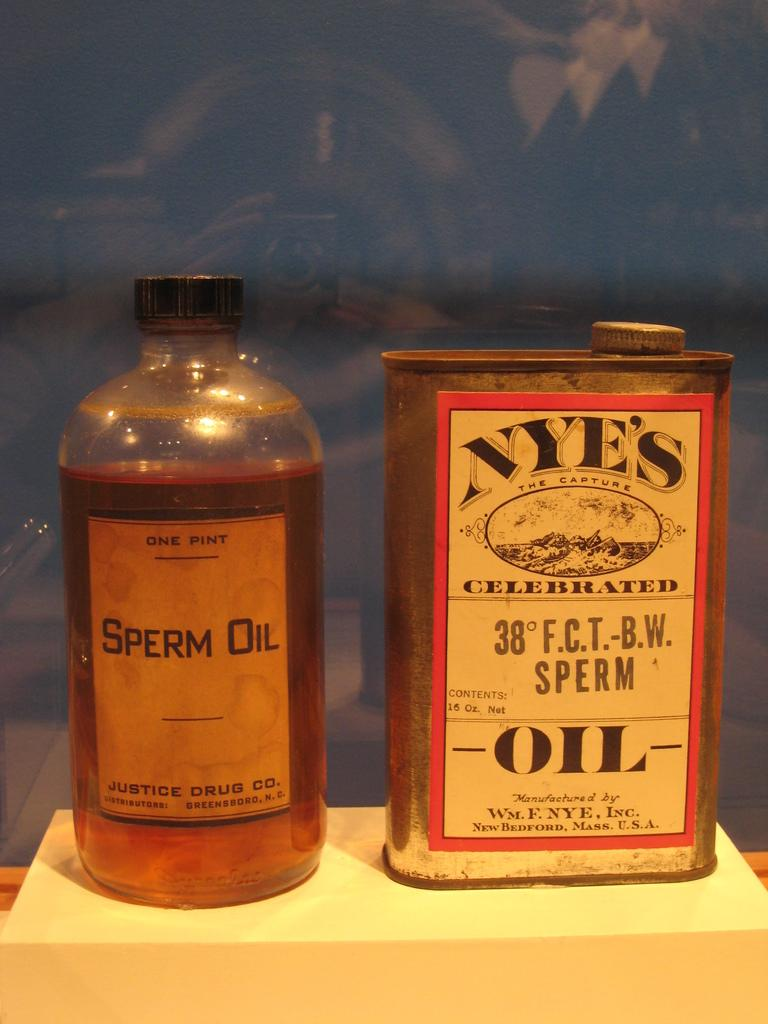<image>
Relay a brief, clear account of the picture shown. Bottle of alcohol next to another bottle that says Sperm Oil. 